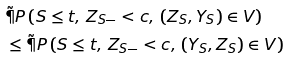Convert formula to latex. <formula><loc_0><loc_0><loc_500><loc_500>& \tilde { \P } P \left ( S \leq t , \, Z _ { S - } < c , \, ( Z _ { S } , Y _ { S } ) \in V \right ) \\ & \leq \tilde { \P } P \left ( S \leq t , \, Z _ { S - } < c , \, ( Y _ { S } , Z _ { S } ) \in V \right )</formula> 